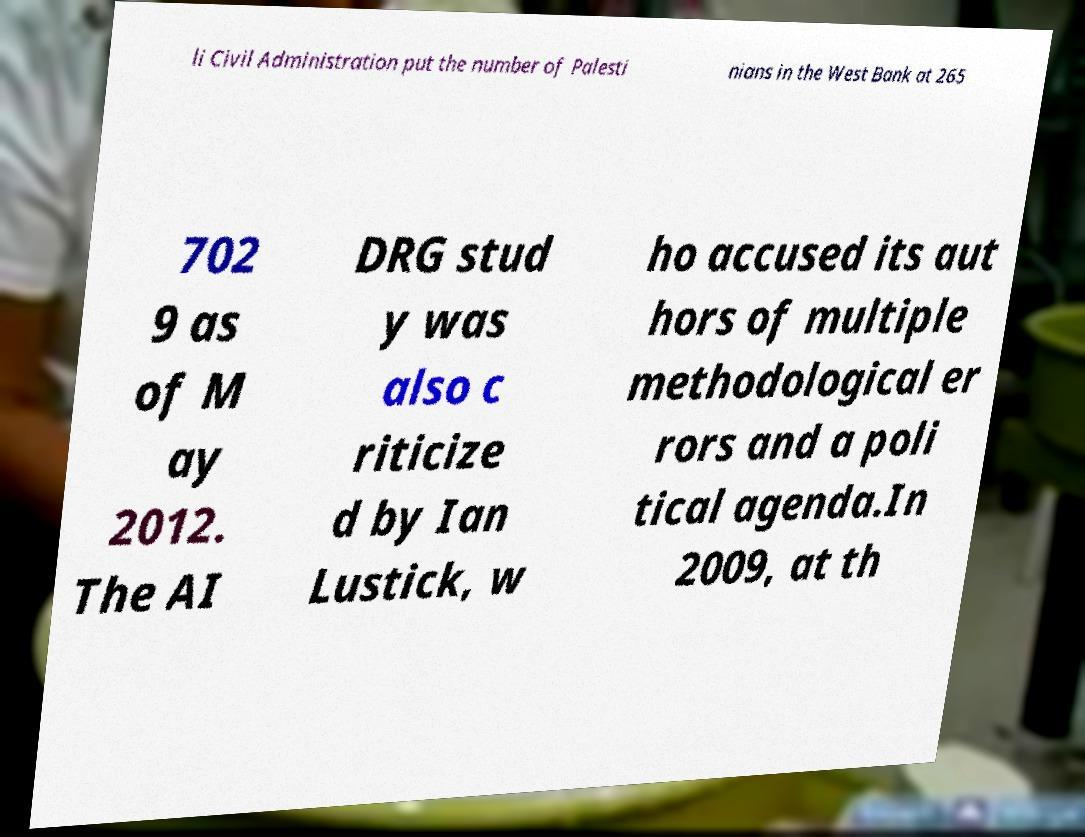There's text embedded in this image that I need extracted. Can you transcribe it verbatim? li Civil Administration put the number of Palesti nians in the West Bank at 265 702 9 as of M ay 2012. The AI DRG stud y was also c riticize d by Ian Lustick, w ho accused its aut hors of multiple methodological er rors and a poli tical agenda.In 2009, at th 